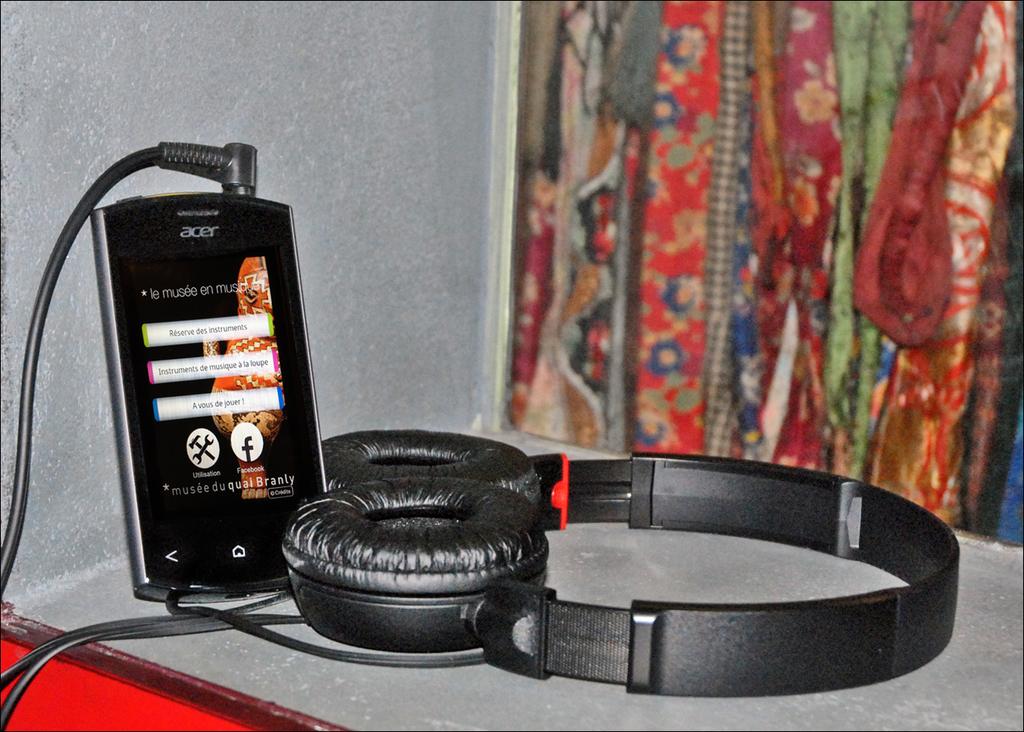What brand is the phone?
Provide a short and direct response. Acer. Name this phone brand?
Make the answer very short. Acer. 